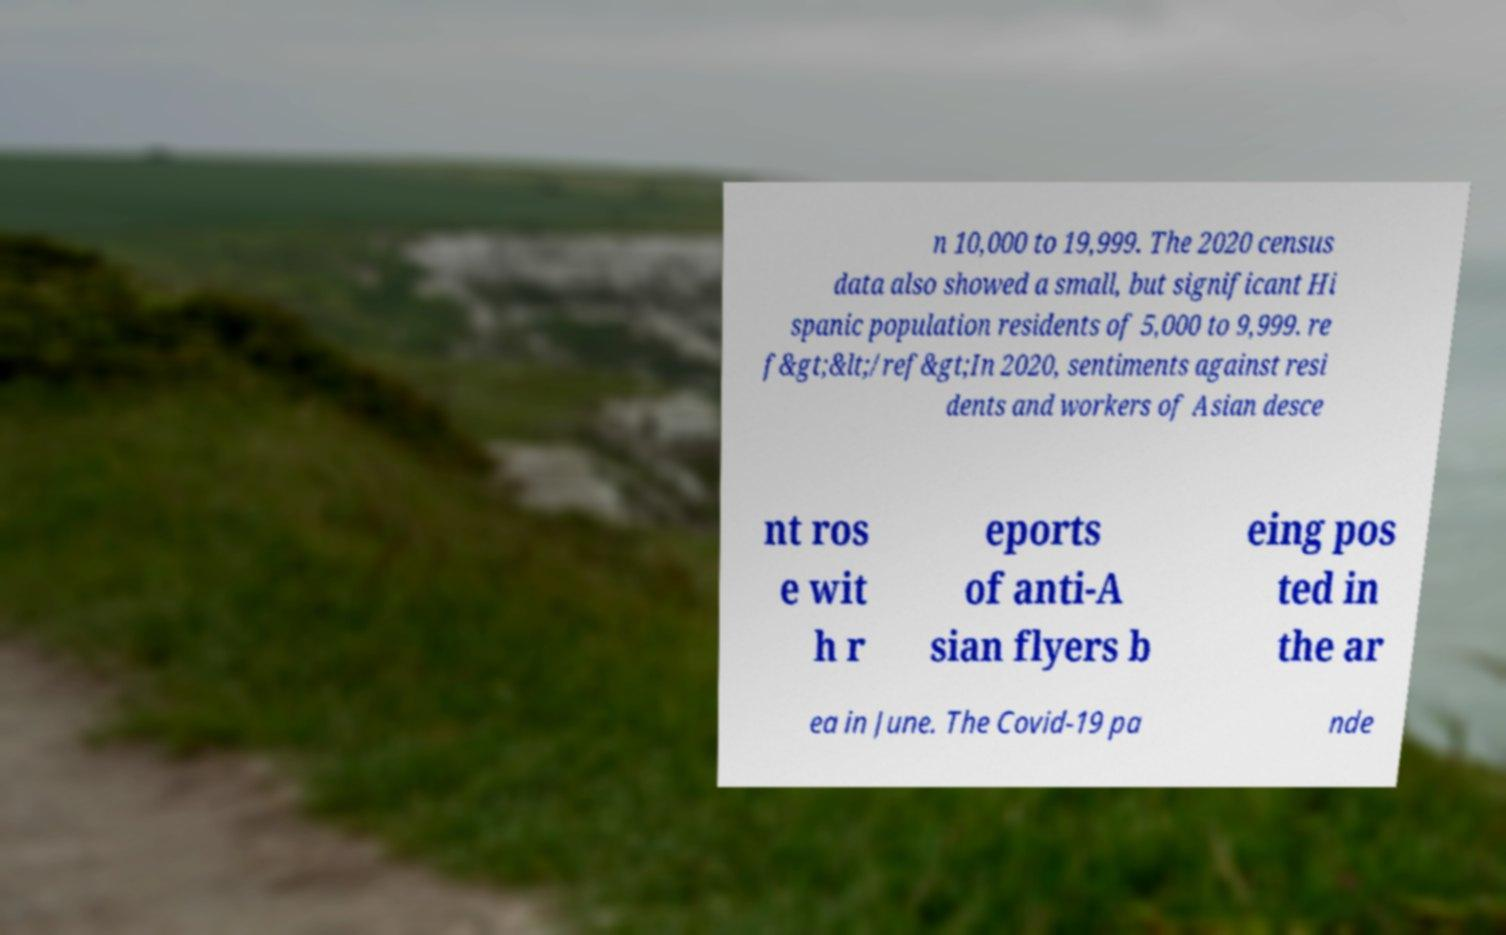Could you extract and type out the text from this image? n 10,000 to 19,999. The 2020 census data also showed a small, but significant Hi spanic population residents of 5,000 to 9,999. re f&gt;&lt;/ref&gt;In 2020, sentiments against resi dents and workers of Asian desce nt ros e wit h r eports of anti-A sian flyers b eing pos ted in the ar ea in June. The Covid-19 pa nde 